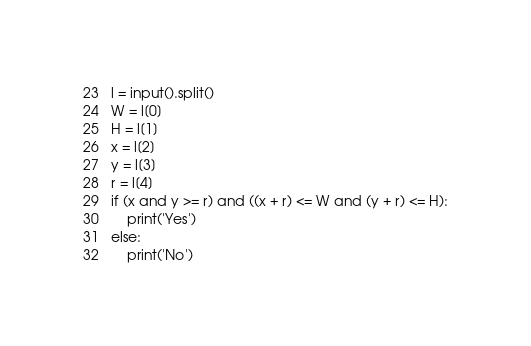Convert code to text. <code><loc_0><loc_0><loc_500><loc_500><_Python_>l = input().split()
W = l[0]
H = l[1]
x = l[2]
y = l[3]
r = l[4]
if (x and y >= r) and ((x + r) <= W and (y + r) <= H):
    print('Yes')
else:
    print('No')</code> 